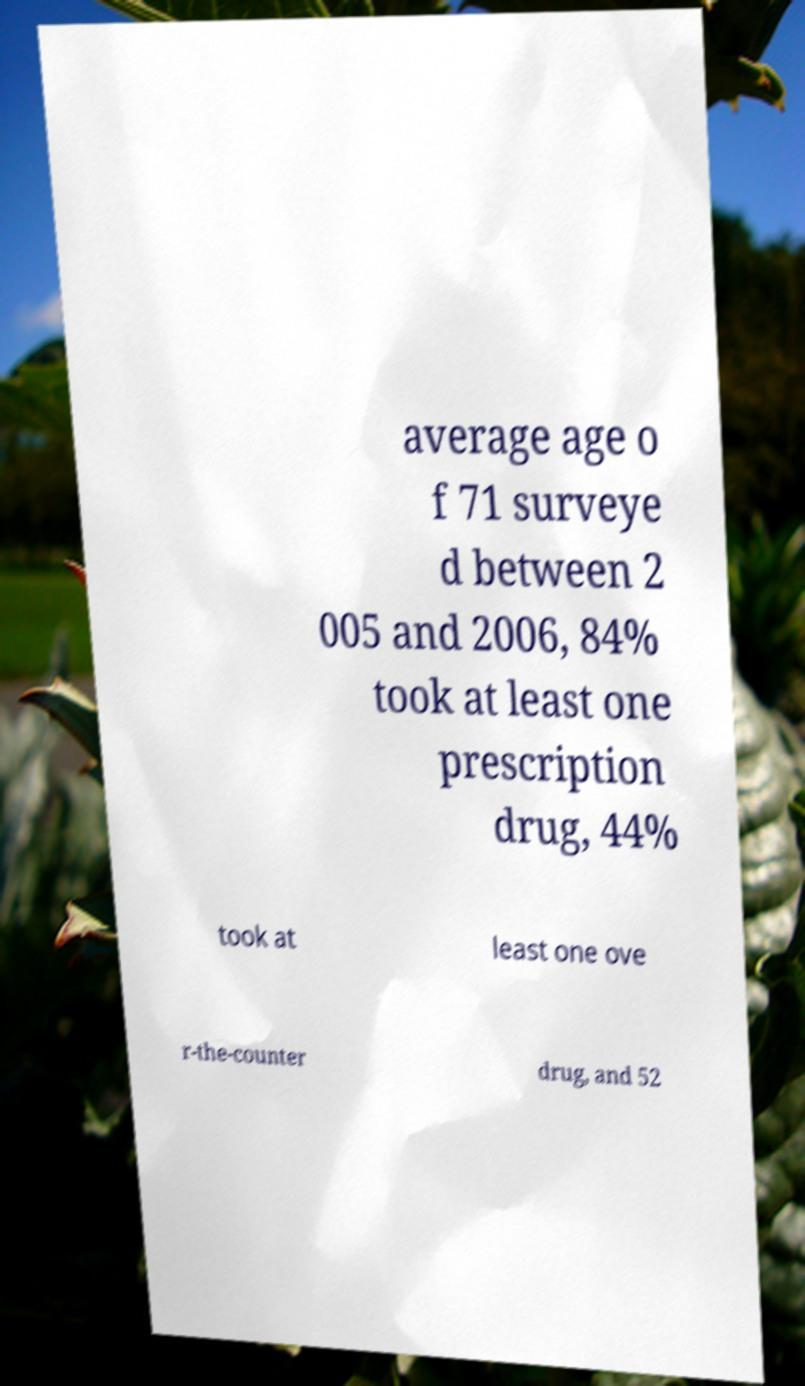I need the written content from this picture converted into text. Can you do that? average age o f 71 surveye d between 2 005 and 2006, 84% took at least one prescription drug, 44% took at least one ove r-the-counter drug, and 52 